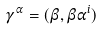Convert formula to latex. <formula><loc_0><loc_0><loc_500><loc_500>\gamma ^ { \alpha } = ( \beta , \beta \alpha ^ { i } )</formula> 